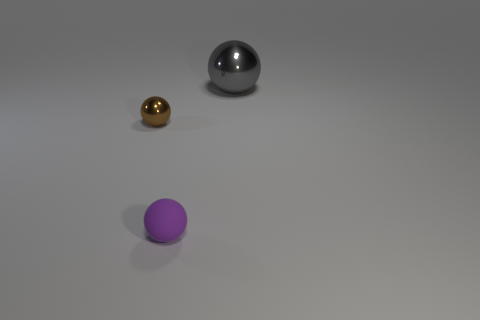Is there anything else that has the same material as the purple sphere?
Offer a very short reply. No. Are there any other things that have the same size as the gray ball?
Provide a short and direct response. No. Are there fewer matte balls than big gray matte cylinders?
Offer a very short reply. No. There is another metal thing that is the same shape as the big gray thing; what is its size?
Offer a very short reply. Small. Is the sphere behind the brown sphere made of the same material as the brown thing?
Provide a short and direct response. Yes. Is the shape of the tiny brown thing the same as the large thing?
Make the answer very short. Yes. What number of things are small objects left of the small purple rubber object or brown objects?
Offer a terse response. 1. There is another brown thing that is made of the same material as the large object; what size is it?
Provide a short and direct response. Small. How many small things have the same color as the tiny metallic sphere?
Offer a terse response. 0. What number of small objects are either purple spheres or shiny spheres?
Provide a succinct answer. 2. 